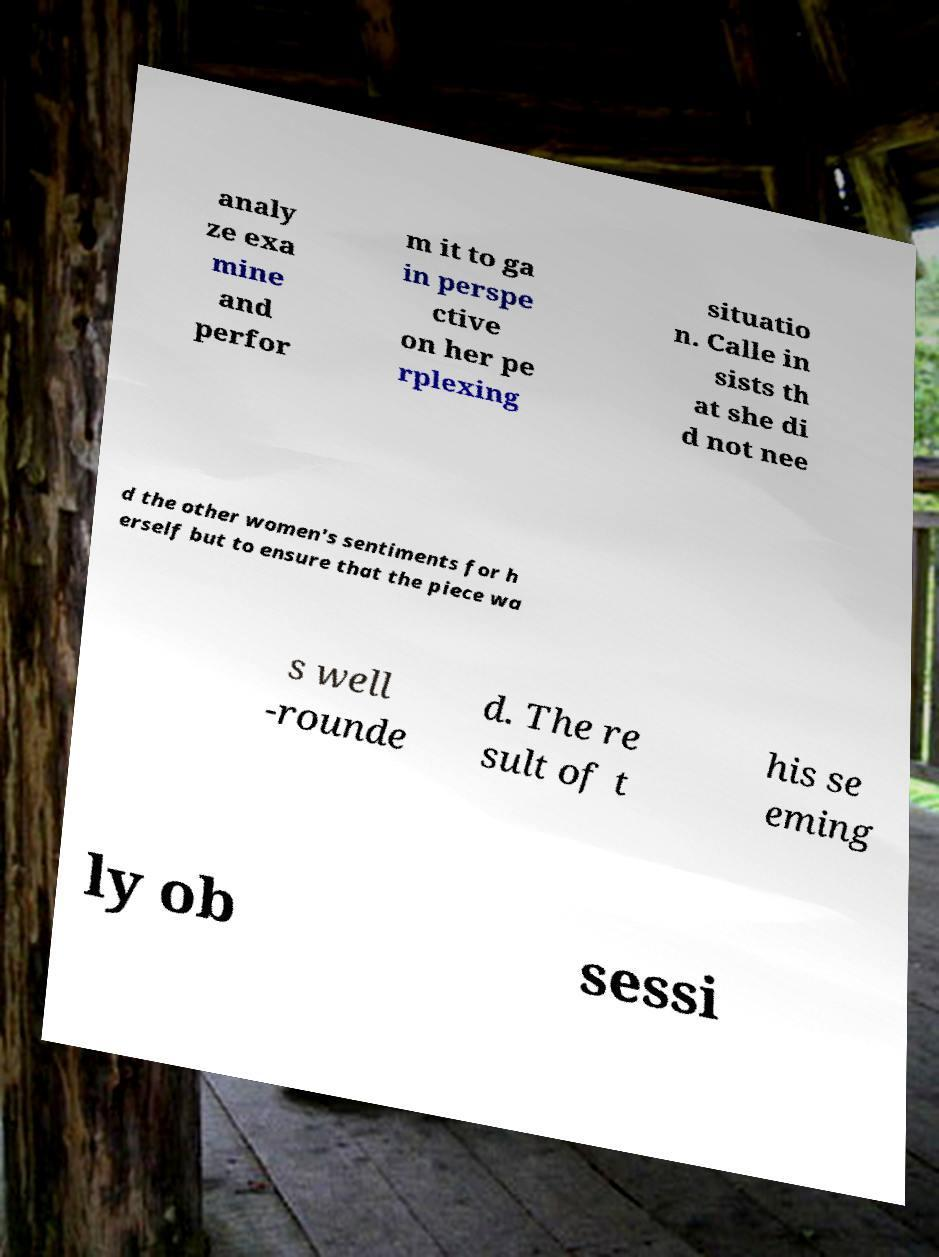Can you accurately transcribe the text from the provided image for me? analy ze exa mine and perfor m it to ga in perspe ctive on her pe rplexing situatio n. Calle in sists th at she di d not nee d the other women's sentiments for h erself but to ensure that the piece wa s well -rounde d. The re sult of t his se eming ly ob sessi 